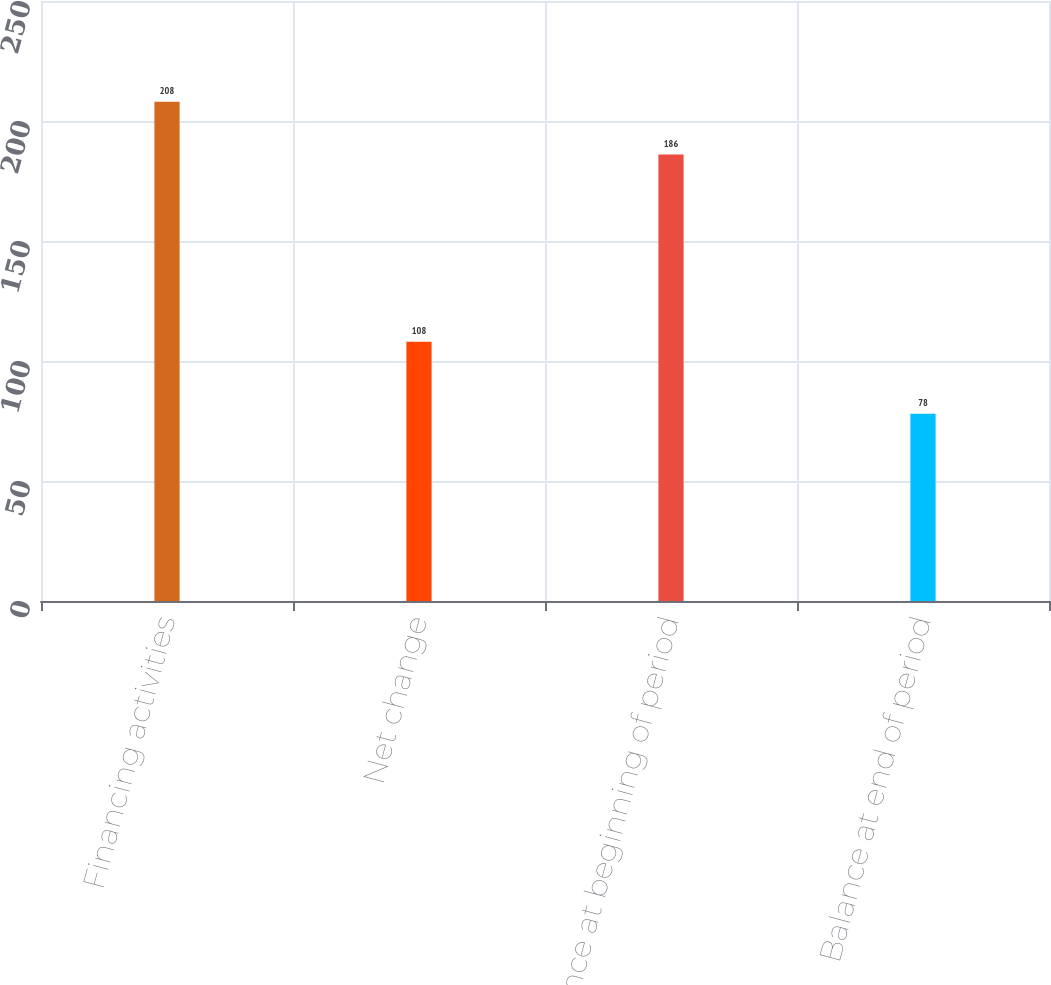Convert chart. <chart><loc_0><loc_0><loc_500><loc_500><bar_chart><fcel>Financing activities<fcel>Net change<fcel>Balance at beginning of period<fcel>Balance at end of period<nl><fcel>208<fcel>108<fcel>186<fcel>78<nl></chart> 